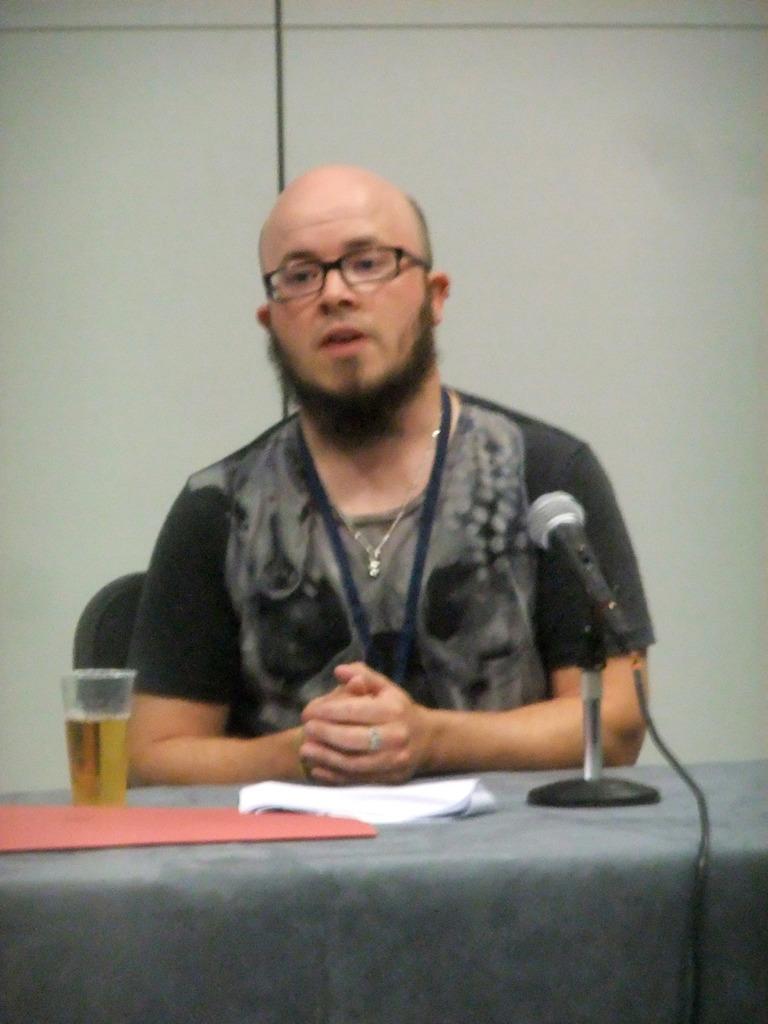Describe this image in one or two sentences. There is a man sitting on the chair wearing a black shirt and some kind of identity card on his neck. He is wearing spectacles. This is a table some paper is placed and I can see a tumbler with some liquid inside it. This is a mike with a mike stand. This is a red colored paper which is placed on the table. I Can see a white colored wall at the background. 